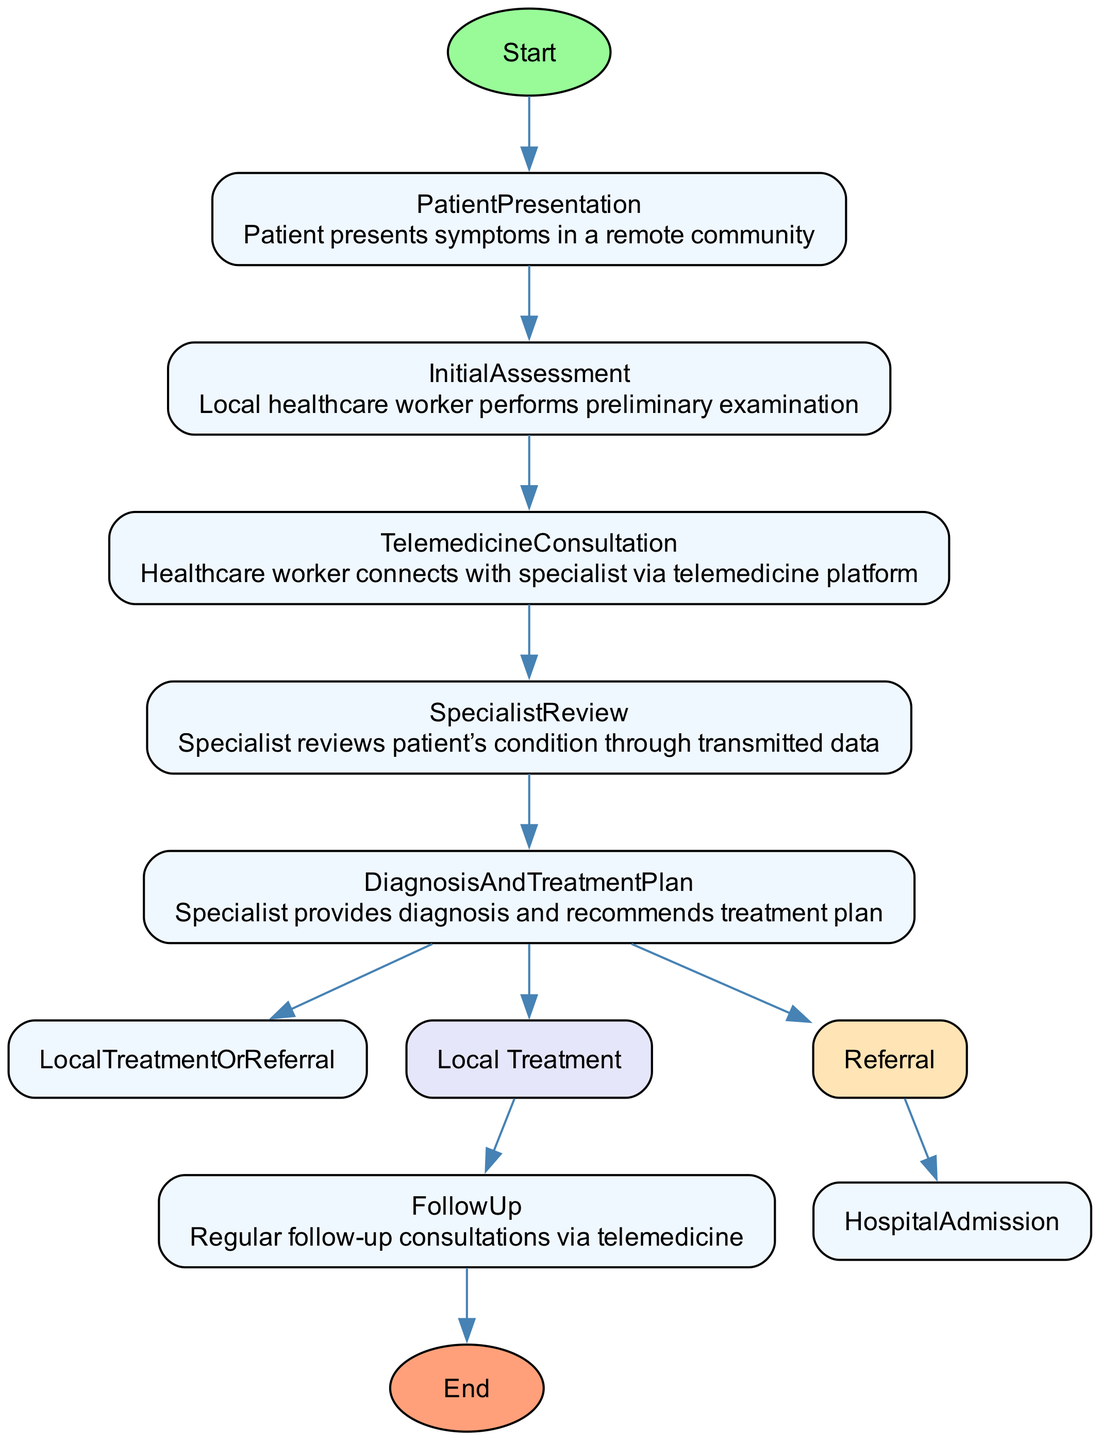What is the starting point of the clinical pathway? The clinical pathway begins with the 'Patient Presentation' node, which represents the moment when a patient presents symptoms in a remote community.
Answer: Patient Presentation What tools are used during the Initial Assessment? In the 'Initial Assessment' node, two tools are listed: a basic medical kit and an initial medical report. These are the tools employed by the local healthcare worker for the preliminary examination.
Answer: Basic medical kit, Initial medical report How many specialists are involved in the Specialist Review phase? The 'Specialist Review' phase lists three types of specialists: a cardiologist, an infectious disease specialist, and a dermatologist. These professionals work collaboratively to review the patient's condition.
Answer: Three What are the two possible next steps after the Diagnosis and Treatment Plan? After the 'Diagnosis and Treatment Plan', there are two potential next steps: 'Local Treatment' and 'Referral'. Depending on the patient's needs, either the local healthcare worker administers treatment or the patient is referred to a hospital.
Answer: Local Treatment, Referral Which platform is used for telemedicine consultations? The 'Telemedicine Consultation' node specifies that the Telessaúde Brasil Redes platform is used for connecting local healthcare workers with specialists for consultations.
Answer: Telessaúde Brasil Redes What tools are needed for the Follow-Up consultations? In the 'Follow-Up' node, the tools required include EHR updates and routine health checks. These resources are essential for maintaining patient care after the initial treatment.
Answer: EHR updates, Routine health checks If the patient requires advanced care, which hospitals can they be referred to? The node detailing 'Referral' lists two hospitals where patients can be referred to if advanced care is required: Hospital das Clínicas in São Paulo and Hospital de Base in Brasília.
Answer: Hospital das Clínicas, Hospital de Base What action is taken during Hospital Admission? Upon reaching the 'Hospital Admission' node, the action taken is admitting the patient to the hospital for advanced care, indicating a transition to more specialized treatment and monitoring.
Answer: Patient admitted to hospital for advanced care What is the final step in the clinical pathway? The final node in the diagram is labelled as 'EndPoint', indicating the conclusion of the clinical pathway after all necessary medical processes have been completed.
Answer: Conclusion of Clinical Pathway 